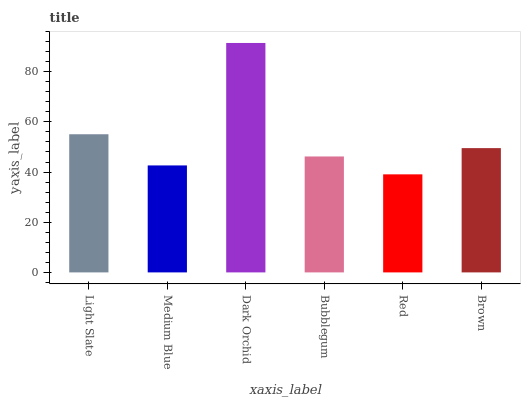Is Red the minimum?
Answer yes or no. Yes. Is Dark Orchid the maximum?
Answer yes or no. Yes. Is Medium Blue the minimum?
Answer yes or no. No. Is Medium Blue the maximum?
Answer yes or no. No. Is Light Slate greater than Medium Blue?
Answer yes or no. Yes. Is Medium Blue less than Light Slate?
Answer yes or no. Yes. Is Medium Blue greater than Light Slate?
Answer yes or no. No. Is Light Slate less than Medium Blue?
Answer yes or no. No. Is Brown the high median?
Answer yes or no. Yes. Is Bubblegum the low median?
Answer yes or no. Yes. Is Medium Blue the high median?
Answer yes or no. No. Is Brown the low median?
Answer yes or no. No. 